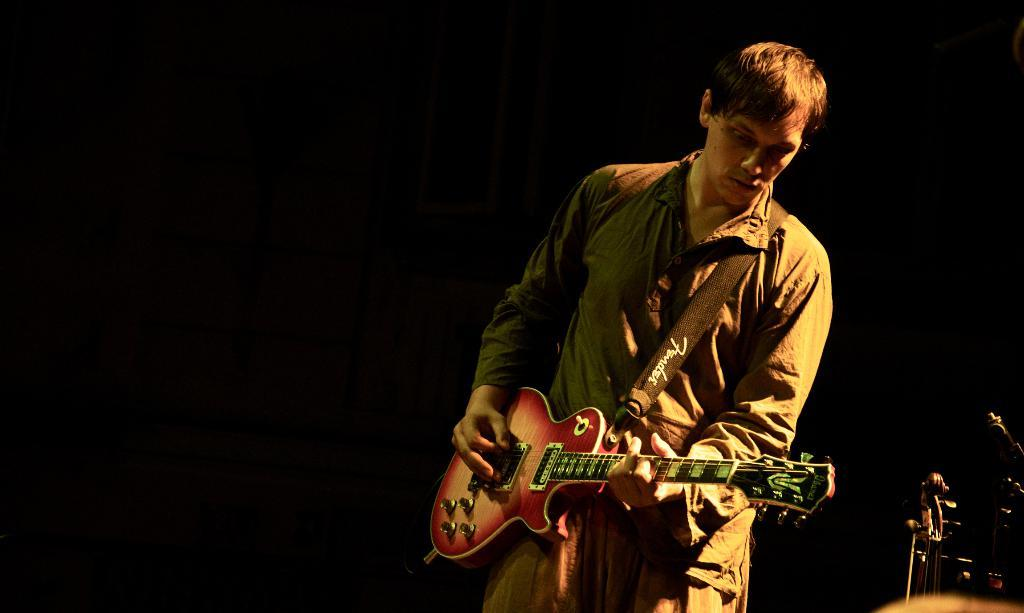What is the person in the image doing? The person is playing a guitar. What direction is the person looking in? The person is looking downwards. What colors can be seen on the guitar? The guitar has a red and white shade. What type of wine is being served in the image? There is no wine present in the image; it features a person playing a guitar. How many bushes are visible in the image? There are no bushes visible in the image; it focuses on a person playing a guitar. 